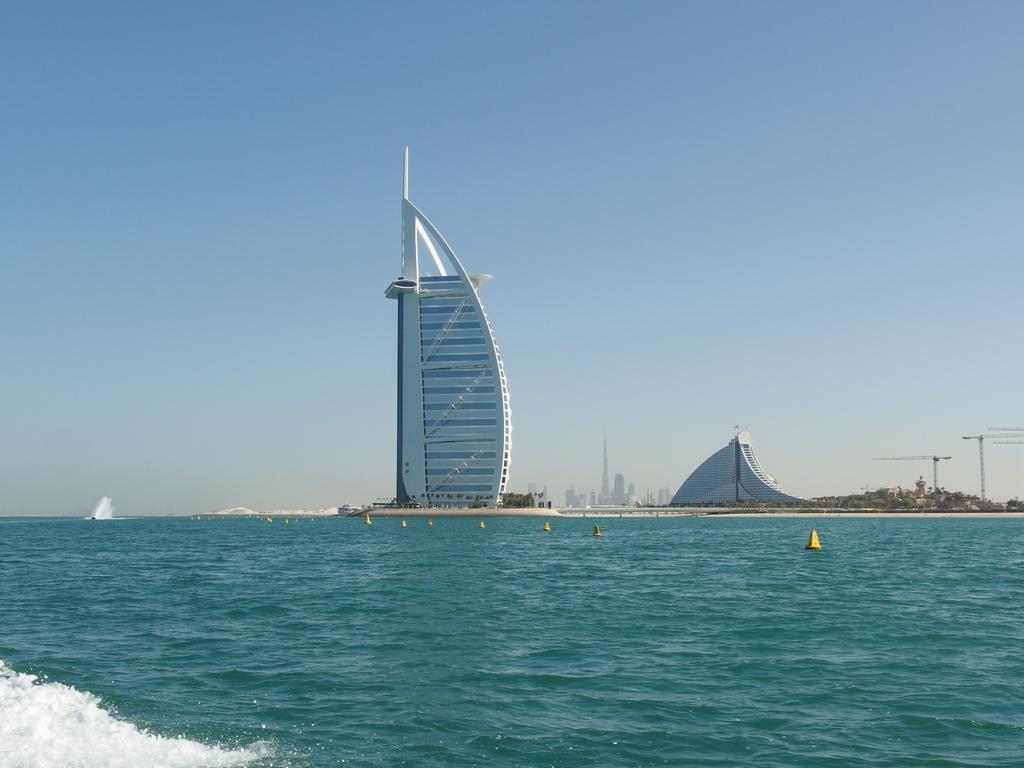In one or two sentences, can you explain what this image depicts? In the center of the image there are buildings and poles. At the bottom there is water. In the background there is sky. 